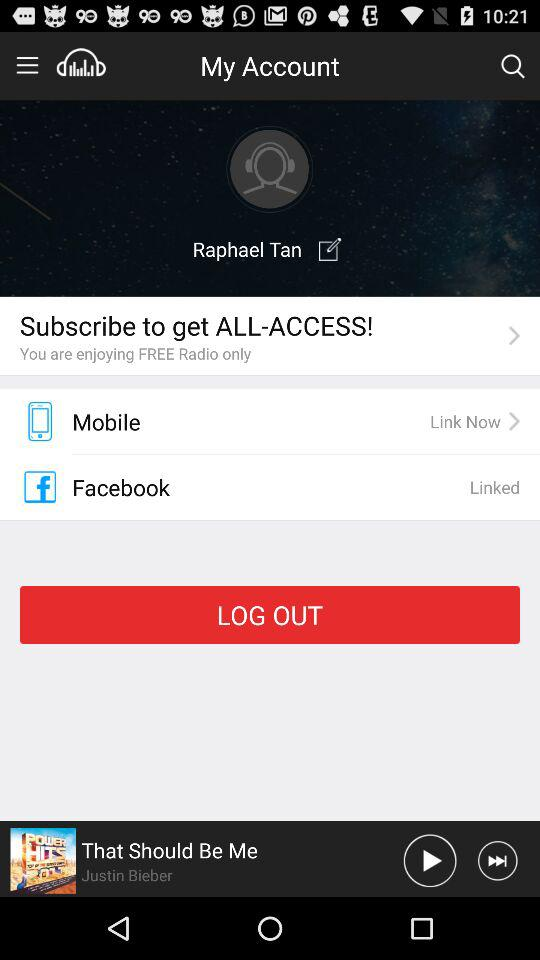Is "Facebook" linked or unlinked?
Answer the question using a single word or phrase. "Facebook" is linked. 